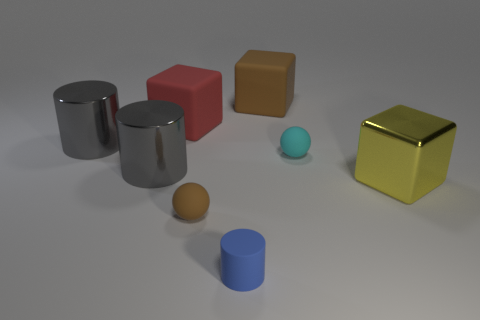Do the small matte cylinder and the metal block have the same color?
Provide a short and direct response. No. What number of small balls are the same material as the tiny cylinder?
Give a very brief answer. 2. There is another tiny ball that is made of the same material as the small cyan ball; what is its color?
Give a very brief answer. Brown. There is a yellow block; does it have the same size as the block on the left side of the blue thing?
Ensure brevity in your answer.  Yes. The large block that is to the left of the tiny thing that is in front of the tiny rubber ball to the left of the matte cylinder is made of what material?
Make the answer very short. Rubber. What number of things are either yellow balls or spheres?
Your answer should be compact. 2. There is a object on the right side of the cyan matte sphere; does it have the same color as the shiny object that is behind the tiny cyan ball?
Your answer should be very brief. No. There is a brown thing that is the same size as the cyan sphere; what is its shape?
Keep it short and to the point. Sphere. How many things are big objects left of the brown matte ball or metallic objects that are on the left side of the red rubber object?
Offer a very short reply. 3. Are there fewer metal blocks than large gray metallic cylinders?
Offer a very short reply. Yes. 